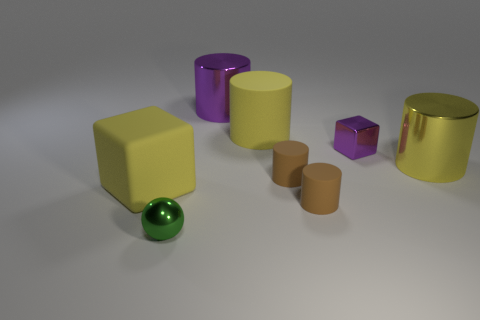Is there a small cyan sphere made of the same material as the large cube?
Offer a terse response. No. Do the purple object to the left of the small purple metallic cube and the big yellow object to the right of the small purple object have the same material?
Ensure brevity in your answer.  Yes. What number of yellow objects are there?
Keep it short and to the point. 3. There is a big rubber thing that is in front of the tiny purple metallic cube; what is its shape?
Make the answer very short. Cube. There is a large purple shiny thing that is on the right side of the green object; is its shape the same as the large rubber object that is right of the big purple metallic cylinder?
Provide a short and direct response. Yes. There is a small purple shiny block; what number of purple shiny blocks are in front of it?
Provide a short and direct response. 0. What color is the cube that is on the left side of the yellow matte cylinder?
Your response must be concise. Yellow. The large rubber thing that is the same shape as the large yellow metal object is what color?
Give a very brief answer. Yellow. Is there anything else that is the same color as the shiny sphere?
Your answer should be very brief. No. Are there more purple metal cylinders than small brown metal things?
Provide a short and direct response. Yes. 